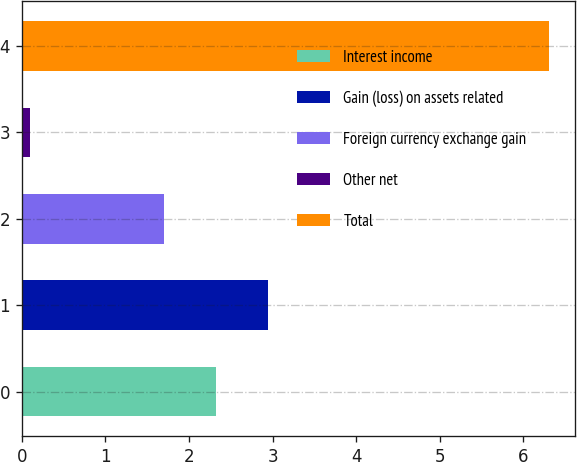<chart> <loc_0><loc_0><loc_500><loc_500><bar_chart><fcel>Interest income<fcel>Gain (loss) on assets related<fcel>Foreign currency exchange gain<fcel>Other net<fcel>Total<nl><fcel>2.32<fcel>2.94<fcel>1.7<fcel>0.1<fcel>6.3<nl></chart> 